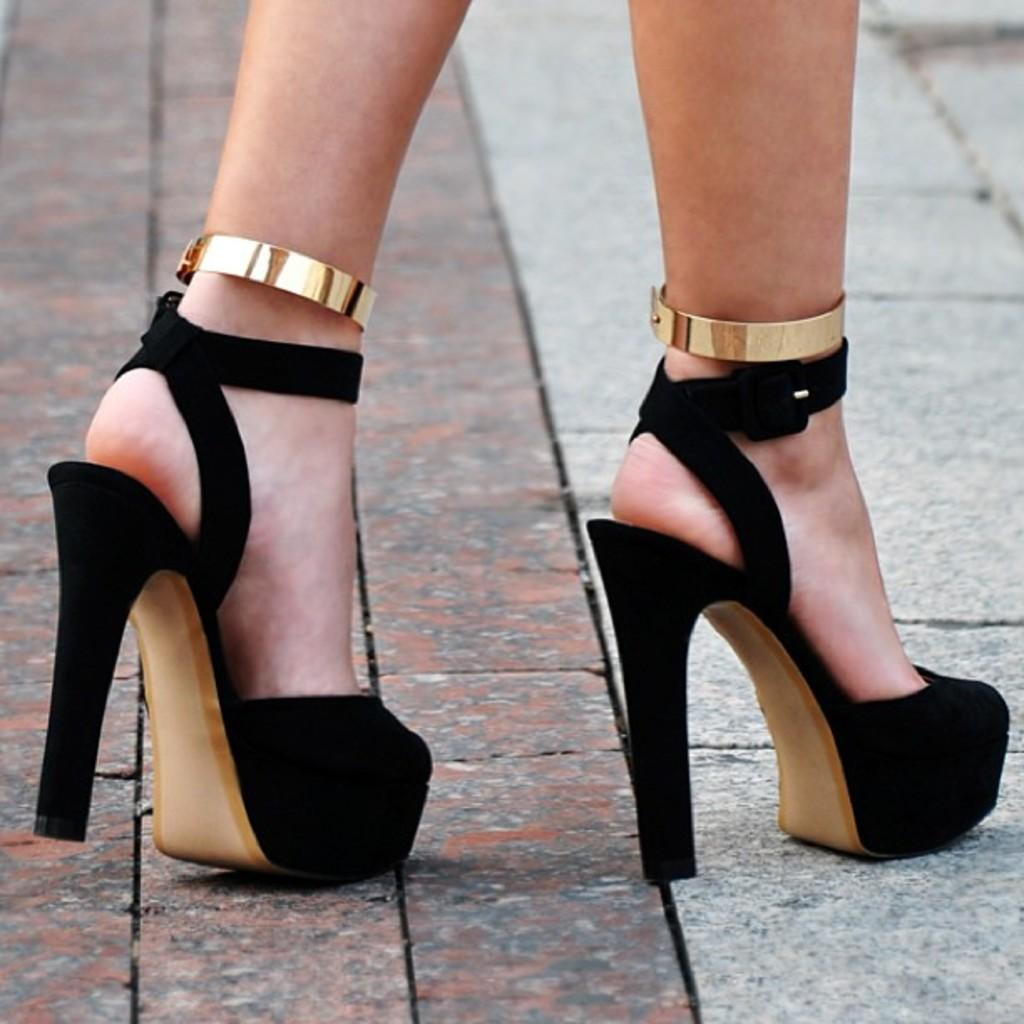What part of a woman can be seen in the image? There are legs of a woman in the image. What type of footwear is the woman wearing? The woman is wearing black color shoes. What type of alarm is the woman holding in the image? There is no alarm present in the image; only the woman's legs and black shoes can be seen. 